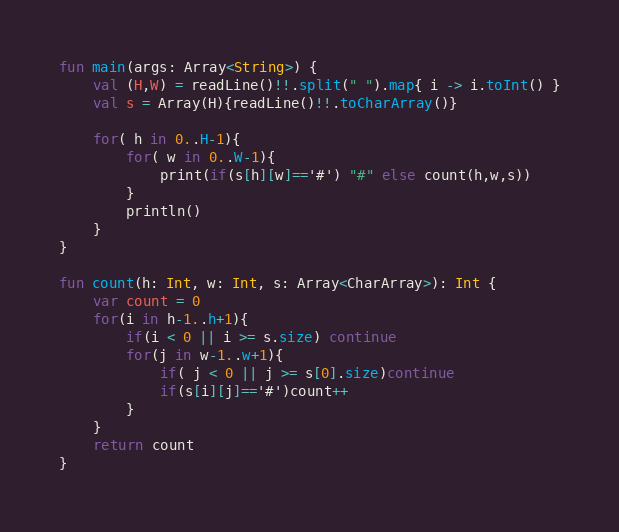Convert code to text. <code><loc_0><loc_0><loc_500><loc_500><_Kotlin_>fun main(args: Array<String>) {
    val (H,W) = readLine()!!.split(" ").map{ i -> i.toInt() }
    val s = Array(H){readLine()!!.toCharArray()}

    for( h in 0..H-1){
        for( w in 0..W-1){
            print(if(s[h][w]=='#') "#" else count(h,w,s))
        }
        println()
    }
}

fun count(h: Int, w: Int, s: Array<CharArray>): Int {
    var count = 0
    for(i in h-1..h+1){
        if(i < 0 || i >= s.size) continue
        for(j in w-1..w+1){
            if( j < 0 || j >= s[0].size)continue
            if(s[i][j]=='#')count++
        }
    }
    return count
}</code> 